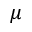Convert formula to latex. <formula><loc_0><loc_0><loc_500><loc_500>\mu</formula> 